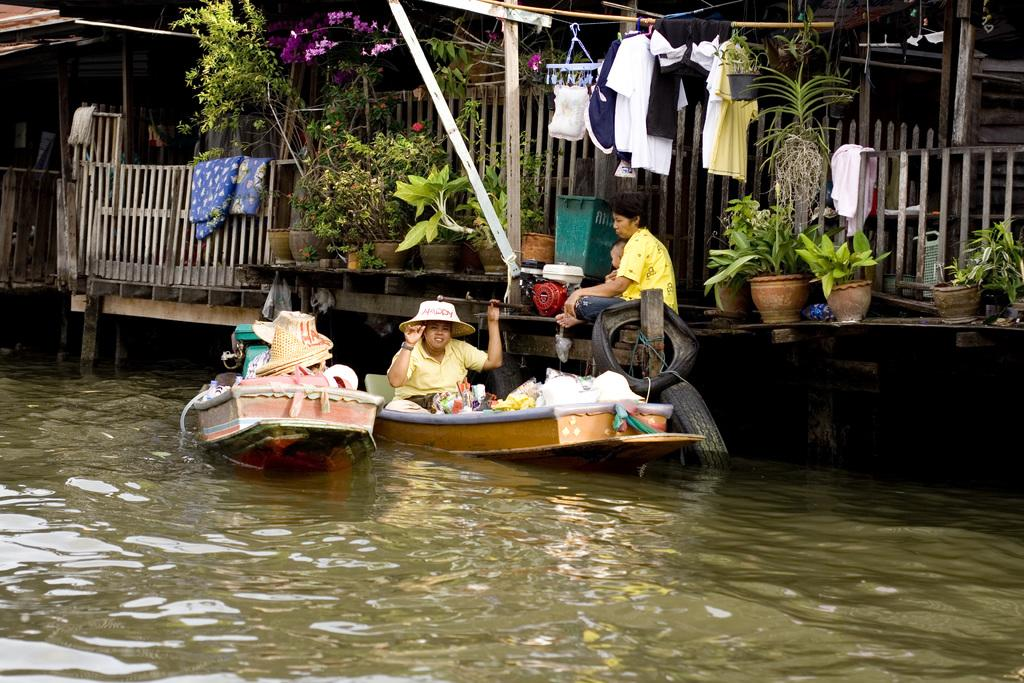What is the main subject of the image? The main subject of the image is a ship. Where is the ship located in the image? The ship is on the water surface in the image. What can be seen on the right side of the image? There are houses on the right side of the image. What type of vegetation is present in front of the houses? There are plants in front of the houses. What type of office can be seen in the image? There is no office present in the image; it features a ship on the water surface and houses with plants in front of them. 